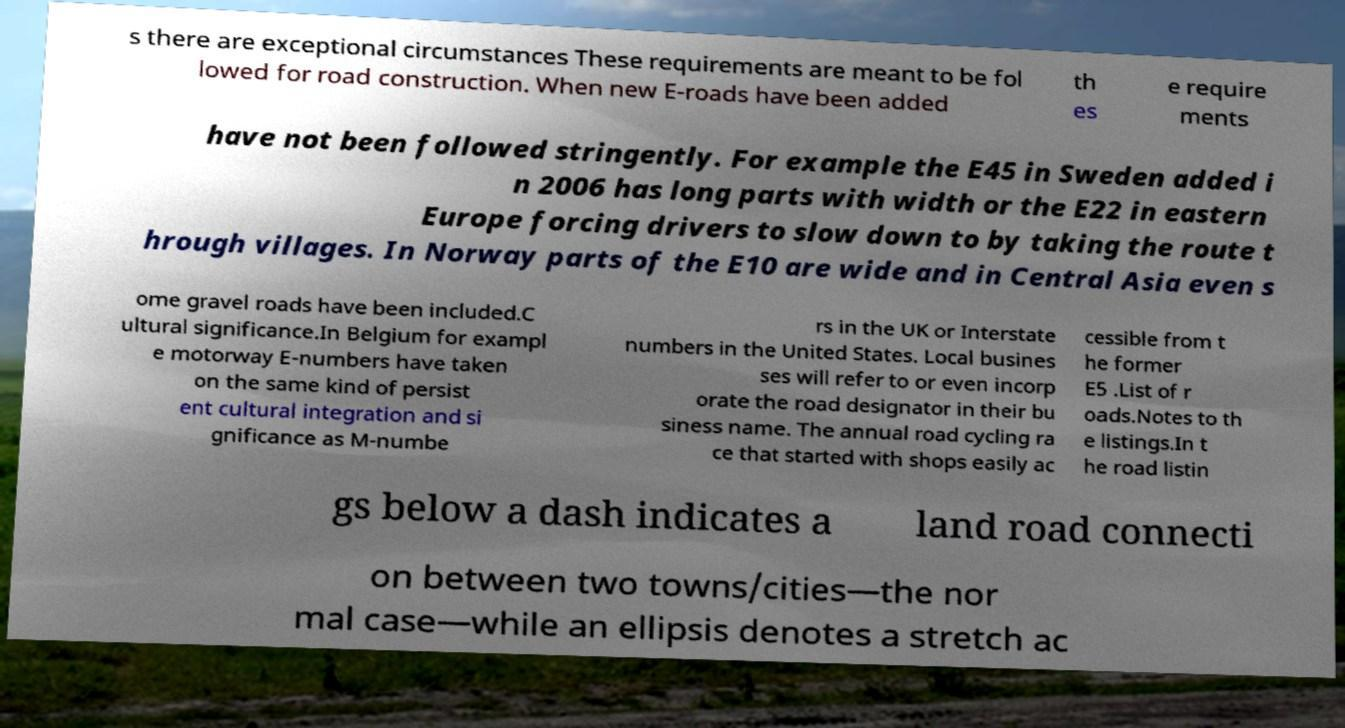I need the written content from this picture converted into text. Can you do that? s there are exceptional circumstances These requirements are meant to be fol lowed for road construction. When new E-roads have been added th es e require ments have not been followed stringently. For example the E45 in Sweden added i n 2006 has long parts with width or the E22 in eastern Europe forcing drivers to slow down to by taking the route t hrough villages. In Norway parts of the E10 are wide and in Central Asia even s ome gravel roads have been included.C ultural significance.In Belgium for exampl e motorway E-numbers have taken on the same kind of persist ent cultural integration and si gnificance as M-numbe rs in the UK or Interstate numbers in the United States. Local busines ses will refer to or even incorp orate the road designator in their bu siness name. The annual road cycling ra ce that started with shops easily ac cessible from t he former E5 .List of r oads.Notes to th e listings.In t he road listin gs below a dash indicates a land road connecti on between two towns/cities—the nor mal case—while an ellipsis denotes a stretch ac 